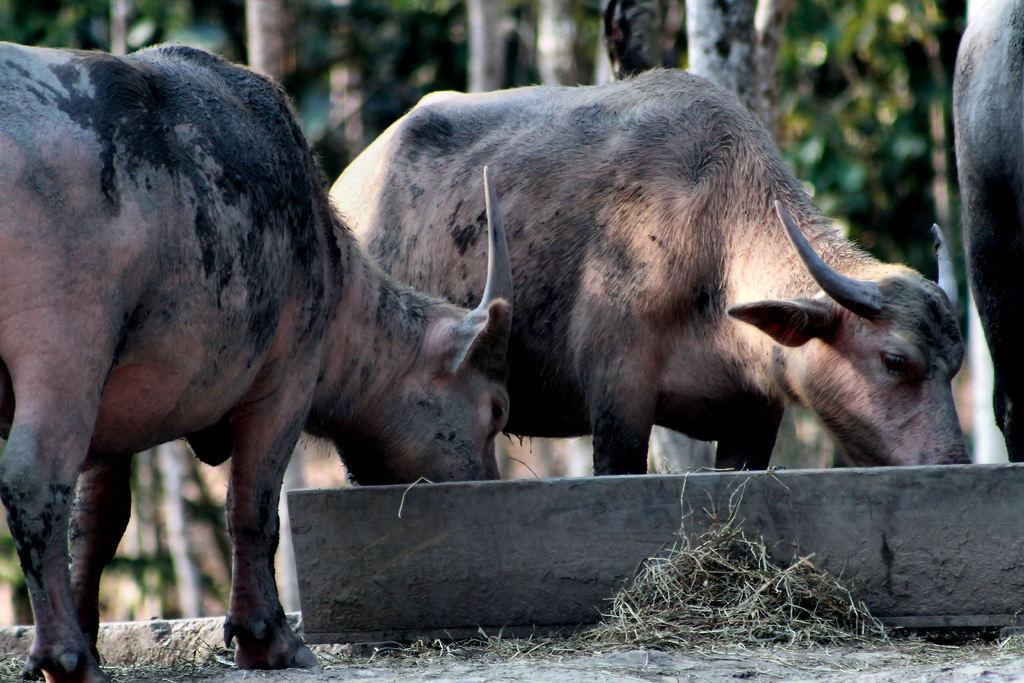What is present at the bottom of the image? Dry grass is visible at the bottom of the image, along with an unspecified object. What type of animals can be seen in the image? There are animals standing in the image. What can be seen in the background of the image? The background of the image has a blurred view, with trees visible. What type of question is being asked by the animals in the image? There is no indication in the image that the animals are asking any questions. Is the governor present in the image? There is no mention of a governor or any political figures in the image. 